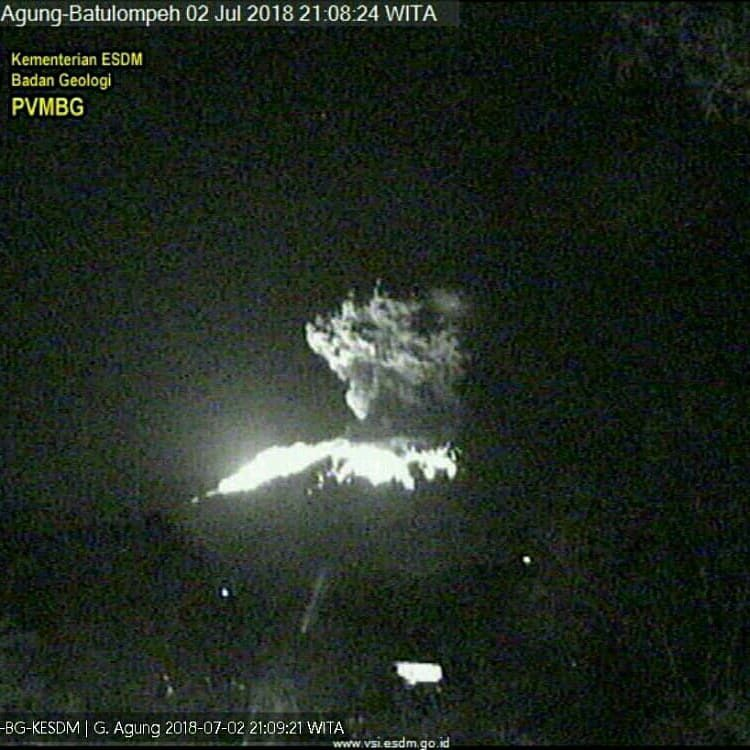Given the current eruption, what immediate actions should be taken to ensure the safety of the local population? Immediate actions to ensure the safety of the local population should include the following steps: 1. Evacuate residents in the vicinity of the volcano, especially those within the danger zones identified by volcanic monitoring agencies. 2. Set up emergency shelters and provide food, medical supplies, and other essential resources for evacuees. 3. Communicate continuously with the public, providing updates about the eruption's status and safety guidelines. 4. Close down access roads and restrict airspace around the volcano to ensure no one inadvertently enters dangerous areas. 5. Coordinate with disaster response teams, including local government bodies, military units, and non-profits, to assist with evacuation and relief efforts. 6. Monitor air quality and provide masks or other protective gear to mitigate the effects of volcanic ash. These steps will help to minimize risks and ensure that any affected individuals receive the support they need promptly. Provide a brief summary of how volcanic eruptions affect agriculture. Volcanic eruptions can have both immediate and long-term effects on agriculture. The immediate impact includes the destruction of crops due to ashfall, lava flows, and pyroclastic flows, which can bury or burn vegetation, making the land temporarily unusable. Ash can also contaminate water sources and disrupt the soil's nutrient balance. However, in the long term, the ash deposited during eruptions can actually improve soil fertility as it breaks down, adding valuable minerals and nutrients to the soil, which can boost agricultural productivity. Farmers affected by an eruption typically require significant support and time to restore their fields to a productive state. 